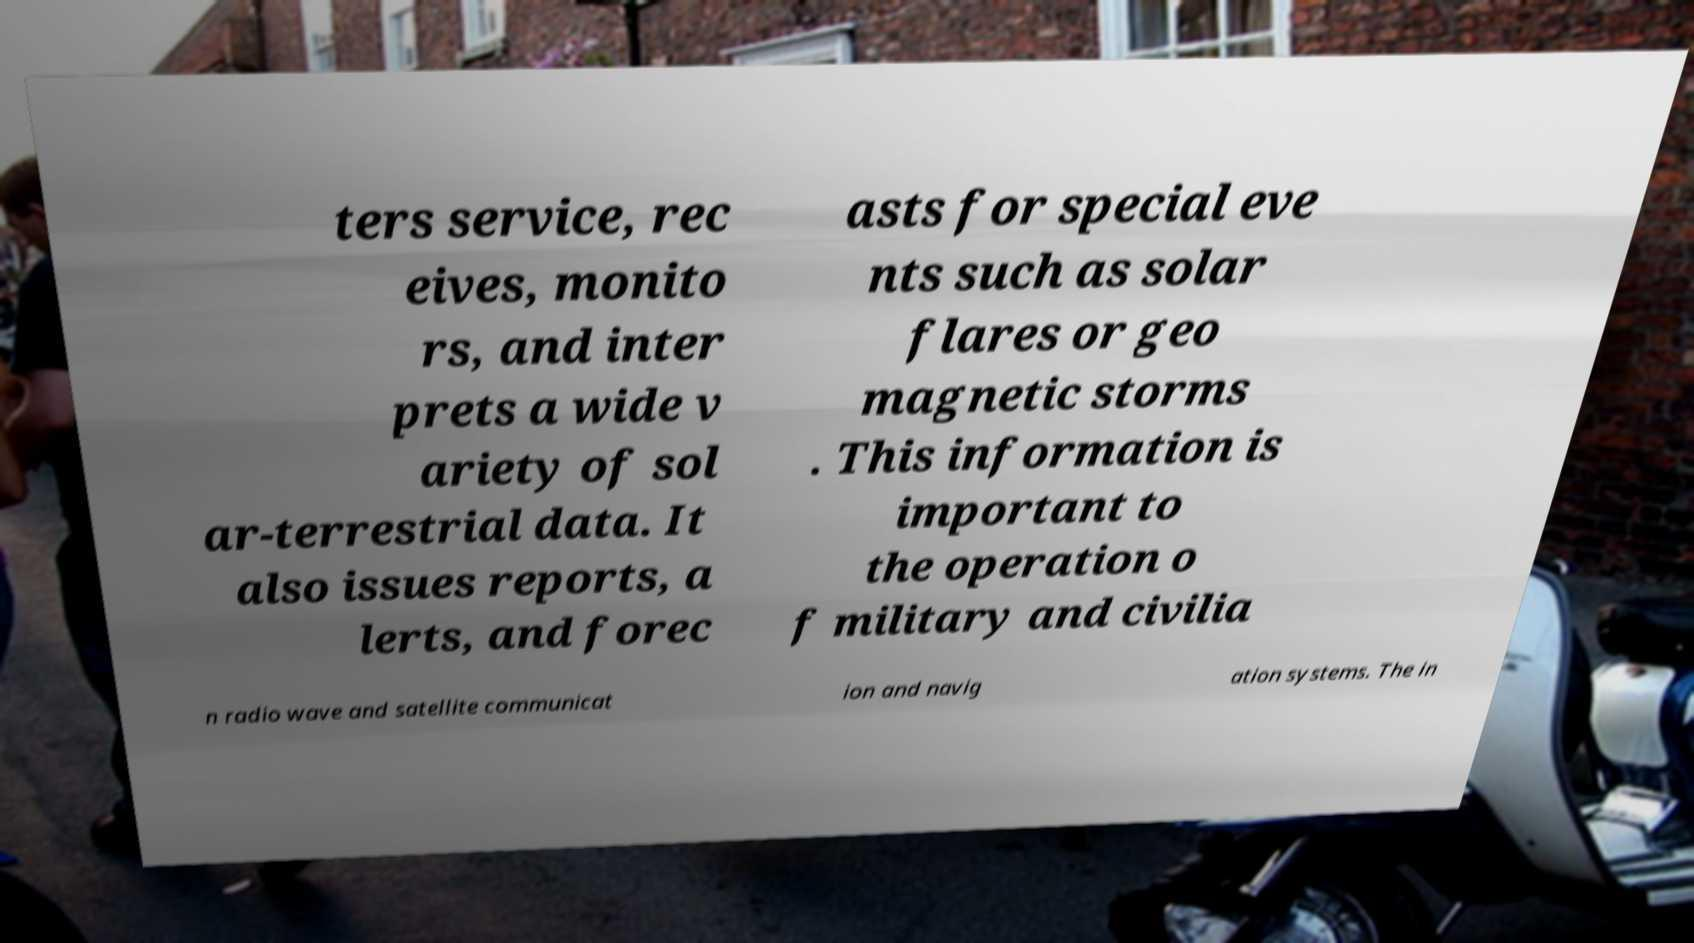I need the written content from this picture converted into text. Can you do that? ters service, rec eives, monito rs, and inter prets a wide v ariety of sol ar-terrestrial data. It also issues reports, a lerts, and forec asts for special eve nts such as solar flares or geo magnetic storms . This information is important to the operation o f military and civilia n radio wave and satellite communicat ion and navig ation systems. The in 